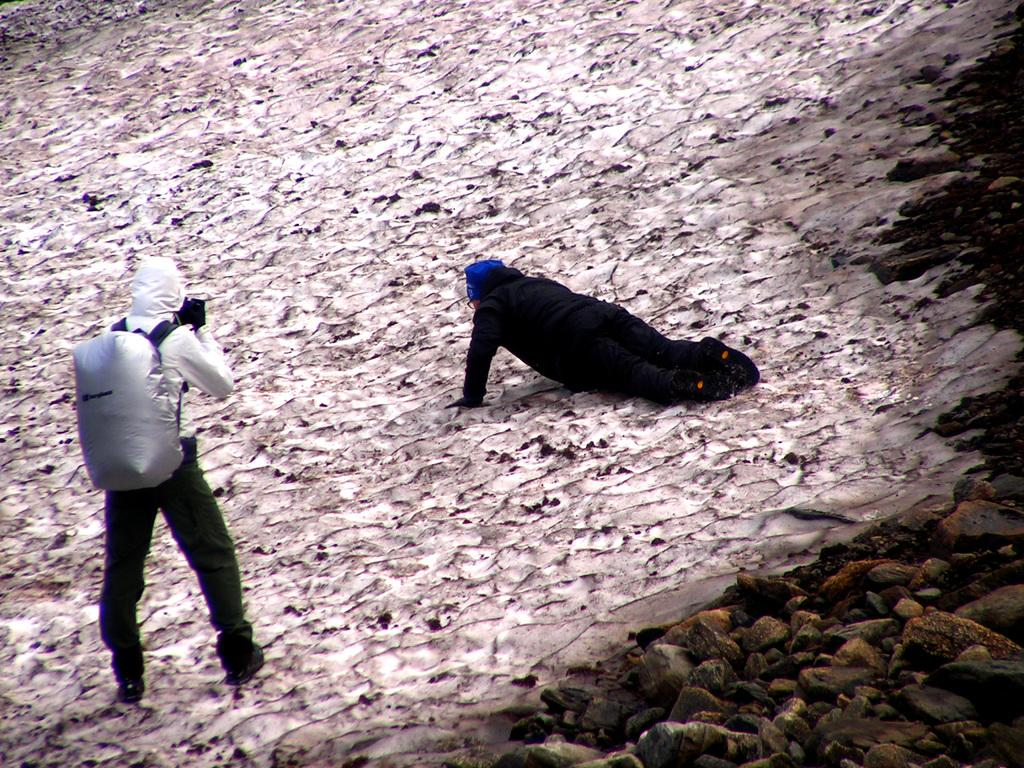How many people are in the image? There are people in the image. Can you describe the position of one of the people? One person is on the left side of the image. What is the person on the left side wearing? The person on the left side is wearing a bag. What type of natural element can be seen in the image? There are rocks visible in the image. What type of notebook is the person on the left side using to write in the image? There is no notebook or writing activity present in the image. 